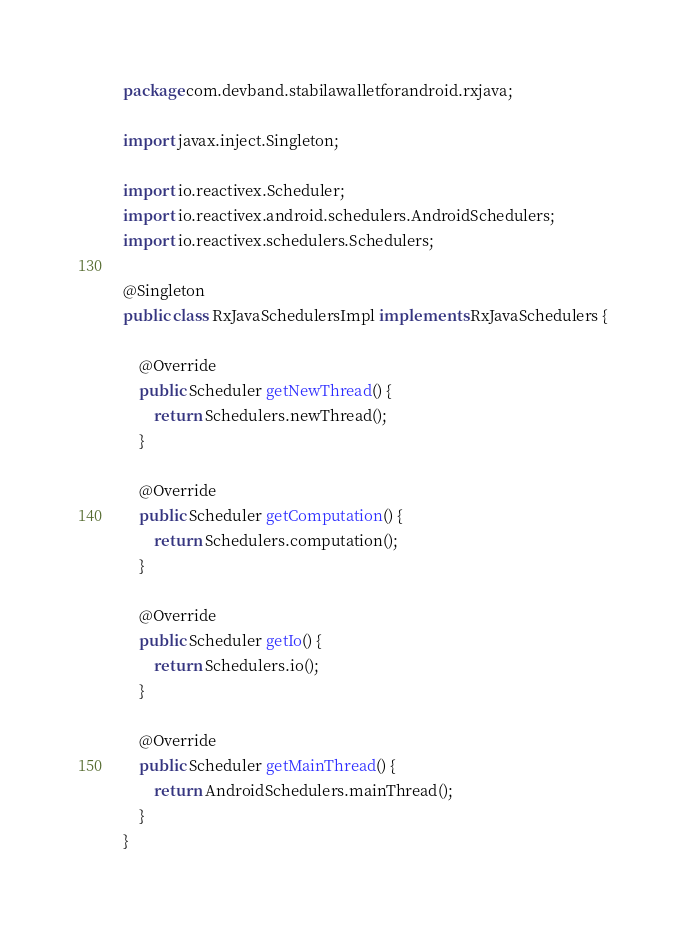<code> <loc_0><loc_0><loc_500><loc_500><_Java_>package com.devband.stabilawalletforandroid.rxjava;

import javax.inject.Singleton;

import io.reactivex.Scheduler;
import io.reactivex.android.schedulers.AndroidSchedulers;
import io.reactivex.schedulers.Schedulers;

@Singleton
public class RxJavaSchedulersImpl implements RxJavaSchedulers {

    @Override
    public Scheduler getNewThread() {
        return Schedulers.newThread();
    }

    @Override
    public Scheduler getComputation() {
        return Schedulers.computation();
    }

    @Override
    public Scheduler getIo() {
        return Schedulers.io();
    }

    @Override
    public Scheduler getMainThread() {
        return AndroidSchedulers.mainThread();
    }
}
</code> 